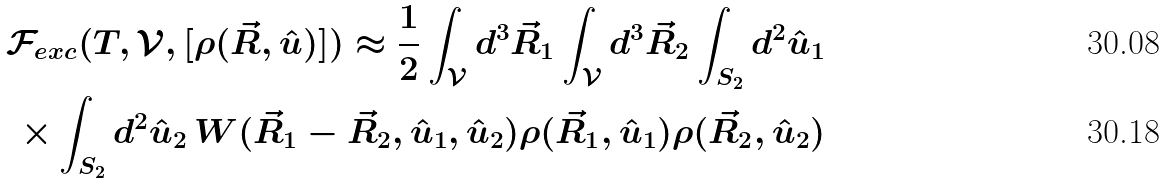Convert formula to latex. <formula><loc_0><loc_0><loc_500><loc_500>\mathcal { F } _ { e x c } ( T , \mathcal { V } , [ \rho ( \vec { R } , \hat { u } ) ] ) \approx \frac { 1 } { 2 } \int _ { \mathcal { V } } d ^ { 3 } \vec { R } _ { 1 } \int _ { \mathcal { V } } d ^ { 3 } \vec { R } _ { 2 } \int _ { S _ { 2 } } d ^ { 2 } \hat { u } _ { 1 } & \\ \times \int _ { S _ { 2 } } d ^ { 2 } \hat { u } _ { 2 } \, W ( \vec { R } _ { 1 } - \vec { R } _ { 2 } , \hat { u } _ { 1 } , \hat { u } _ { 2 } ) \rho ( \vec { R } _ { 1 } , \hat { u } _ { 1 } ) \rho ( \vec { R } _ { 2 } , \hat { u } _ { 2 } ) &</formula> 